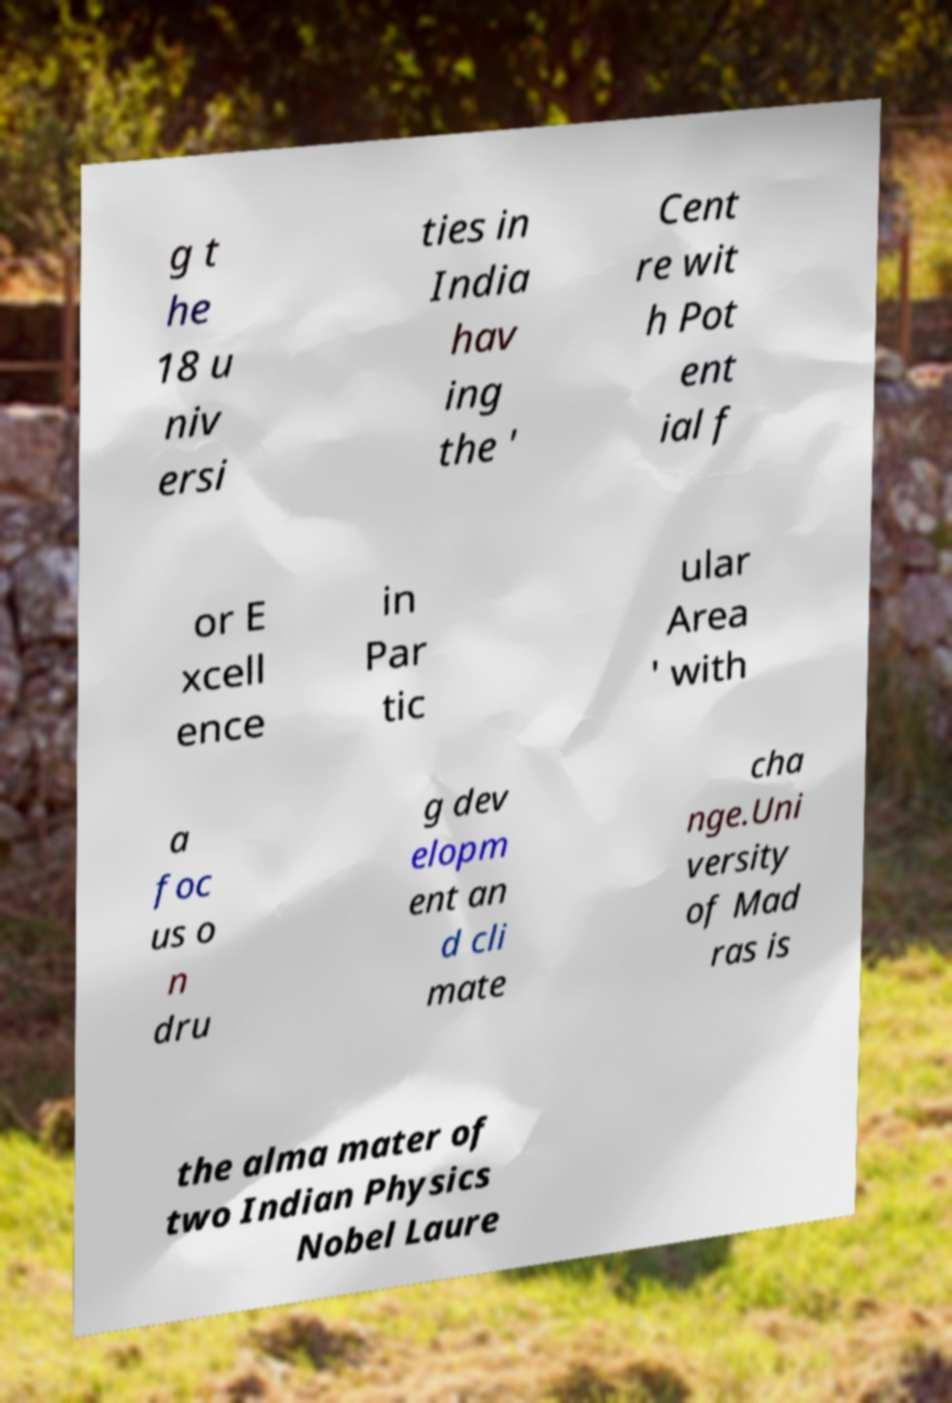For documentation purposes, I need the text within this image transcribed. Could you provide that? g t he 18 u niv ersi ties in India hav ing the ' Cent re wit h Pot ent ial f or E xcell ence in Par tic ular Area ' with a foc us o n dru g dev elopm ent an d cli mate cha nge.Uni versity of Mad ras is the alma mater of two Indian Physics Nobel Laure 